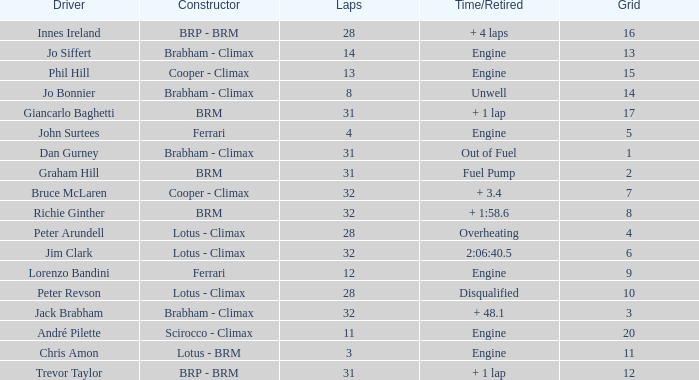What is the average grid for jack brabham going over 32 laps? None. 